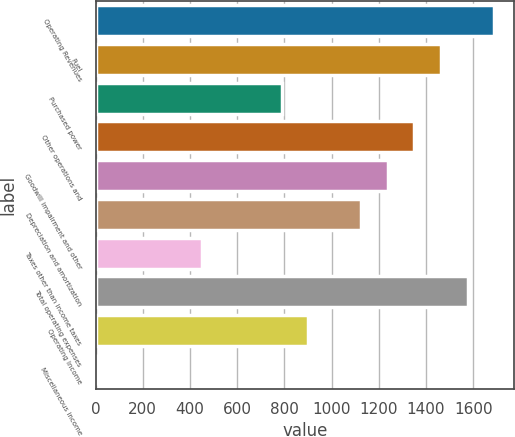<chart> <loc_0><loc_0><loc_500><loc_500><bar_chart><fcel>Operating Revenues<fcel>Fuel<fcel>Purchased power<fcel>Other operations and<fcel>Goodwill impairment and other<fcel>Depreciation and amortization<fcel>Taxes other than income taxes<fcel>Total operating expenses<fcel>Operating Income<fcel>Miscellaneous income<nl><fcel>1688.5<fcel>1463.5<fcel>788.5<fcel>1351<fcel>1238.5<fcel>1126<fcel>451<fcel>1576<fcel>901<fcel>1<nl></chart> 